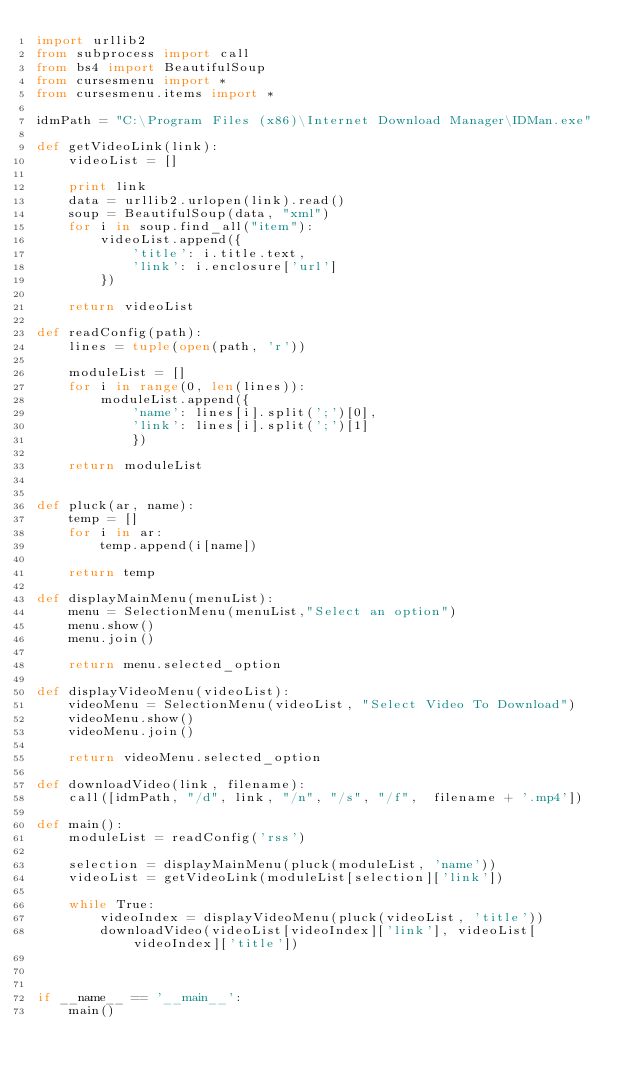Convert code to text. <code><loc_0><loc_0><loc_500><loc_500><_Python_>import urllib2
from subprocess import call
from bs4 import BeautifulSoup
from cursesmenu import *
from cursesmenu.items import *

idmPath = "C:\Program Files (x86)\Internet Download Manager\IDMan.exe"

def getVideoLink(link):
	videoList = []

	print link
	data = urllib2.urlopen(link).read()
	soup = BeautifulSoup(data, "xml")
	for i in soup.find_all("item"):
		videoList.append({
			'title': i.title.text,
			'link': i.enclosure['url']
		})

	return videoList

def readConfig(path):
	lines = tuple(open(path, 'r'))

	moduleList = []
	for i in range(0, len(lines)):
		moduleList.append({
			'name': lines[i].split(';')[0],
			'link': lines[i].split(';')[1]
			})

	return moduleList


def pluck(ar, name):
	temp = []
	for i in ar:
		temp.append(i[name])

	return temp

def displayMainMenu(menuList):
	menu = SelectionMenu(menuList,"Select an option")
	menu.show()
	menu.join()

	return menu.selected_option

def displayVideoMenu(videoList):
	videoMenu = SelectionMenu(videoList, "Select Video To Download")
	videoMenu.show()
	videoMenu.join()		

	return videoMenu.selected_option	

def downloadVideo(link, filename):
	call([idmPath, "/d", link, "/n", "/s", "/f",  filename + '.mp4'])

def main():
	moduleList = readConfig('rss')

	selection = displayMainMenu(pluck(moduleList, 'name'))
	videoList = getVideoLink(moduleList[selection]['link'])

	while True:
		videoIndex = displayVideoMenu(pluck(videoList, 'title'))
		downloadVideo(videoList[videoIndex]['link'], videoList[videoIndex]['title'])



if __name__ == '__main__':
	main()
</code> 